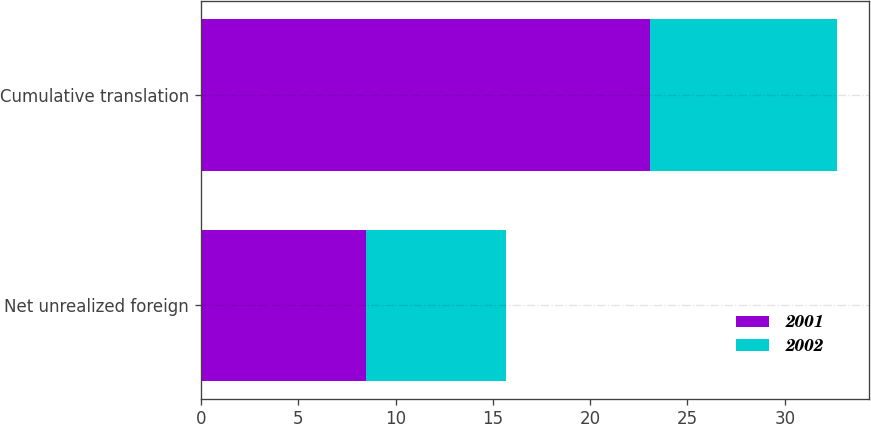<chart> <loc_0><loc_0><loc_500><loc_500><stacked_bar_chart><ecel><fcel>Net unrealized foreign<fcel>Cumulative translation<nl><fcel>2001<fcel>8.5<fcel>23.1<nl><fcel>2002<fcel>7.2<fcel>9.6<nl></chart> 